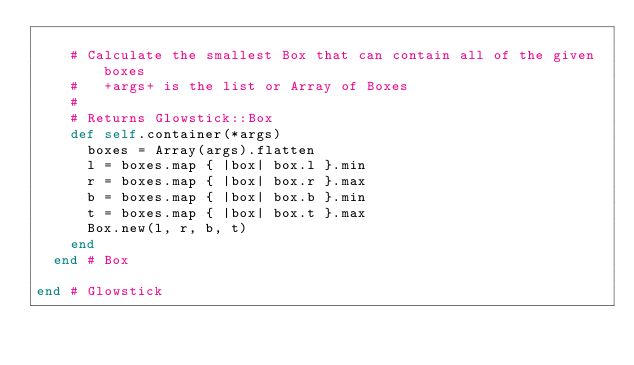Convert code to text. <code><loc_0><loc_0><loc_500><loc_500><_Ruby_>    
    # Calculate the smallest Box that can contain all of the given boxes
    #   +args+ is the list or Array of Boxes
    #
    # Returns Glowstick::Box
    def self.container(*args)
      boxes = Array(args).flatten
      l = boxes.map { |box| box.l }.min
      r = boxes.map { |box| box.r }.max
      b = boxes.map { |box| box.b }.min
      t = boxes.map { |box| box.t }.max
      Box.new(l, r, b, t)
    end
  end # Box

end # Glowstick</code> 